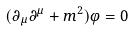<formula> <loc_0><loc_0><loc_500><loc_500>( \partial _ { \mu } \partial ^ { \mu } + m ^ { 2 } ) \varphi = 0</formula> 